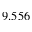<formula> <loc_0><loc_0><loc_500><loc_500>9 . 5 5 6</formula> 